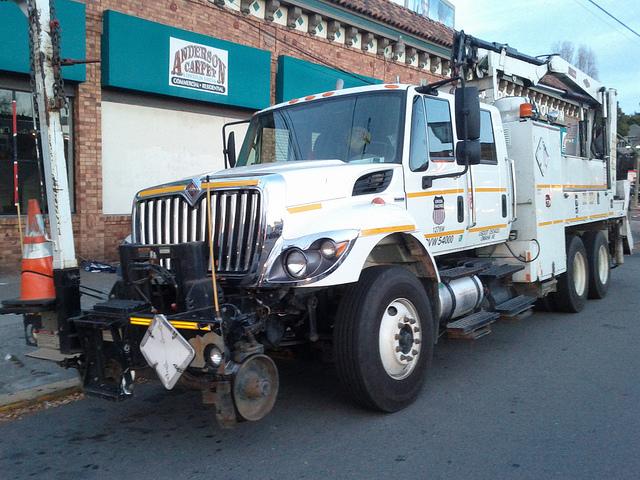How many wheels does the truck have?
Give a very brief answer. 10. Do you need a special license to drive this vehicle?
Write a very short answer. Yes. How many people are in the truck lift?
Be succinct. 1. What color are the stripes on this truck?
Concise answer only. Yellow. 